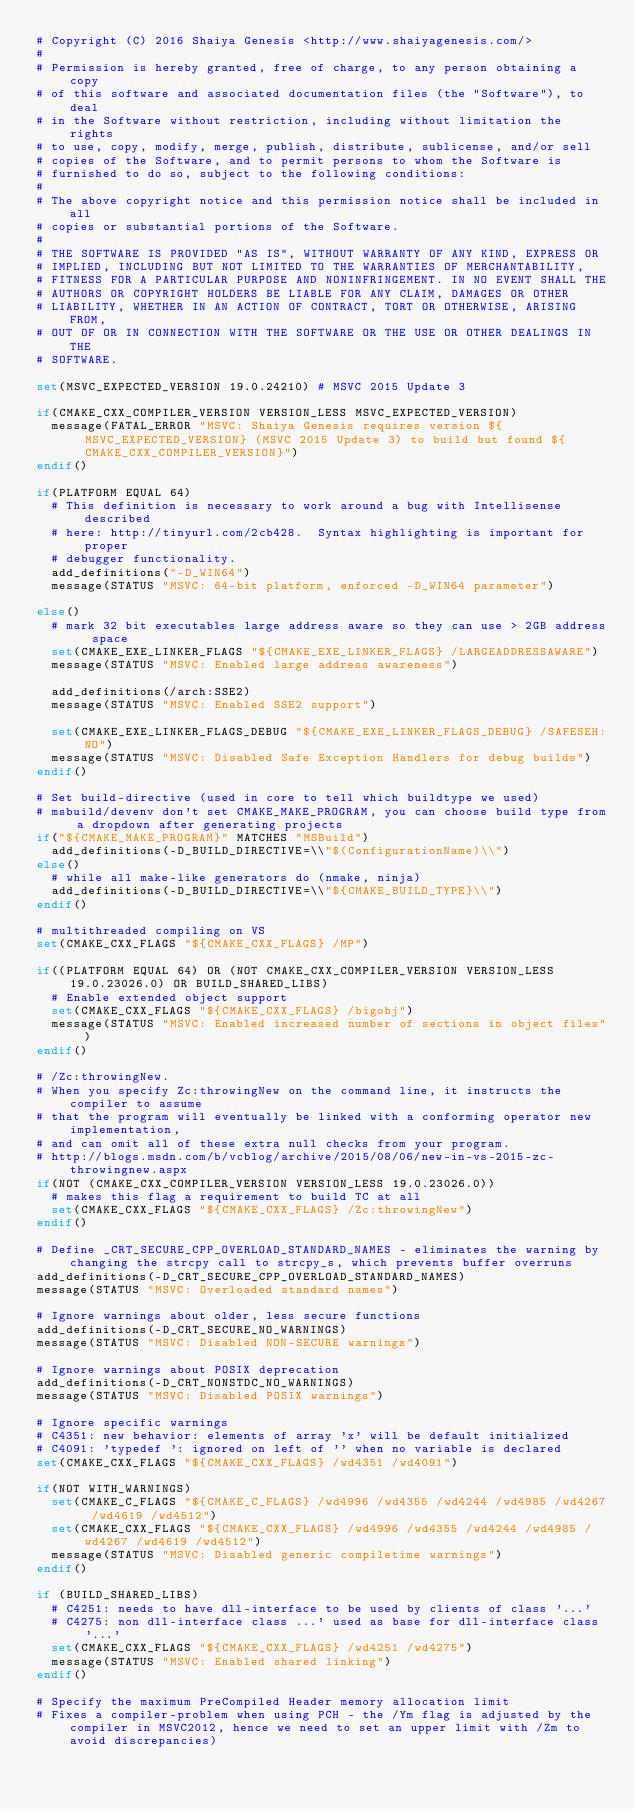<code> <loc_0><loc_0><loc_500><loc_500><_CMake_># Copyright (C) 2016 Shaiya Genesis <http://www.shaiyagenesis.com/>
#
# Permission is hereby granted, free of charge, to any person obtaining a copy
# of this software and associated documentation files (the "Software"), to deal
# in the Software without restriction, including without limitation the rights
# to use, copy, modify, merge, publish, distribute, sublicense, and/or sell
# copies of the Software, and to permit persons to whom the Software is
# furnished to do so, subject to the following conditions:
#
# The above copyright notice and this permission notice shall be included in all
# copies or substantial portions of the Software.
#
# THE SOFTWARE IS PROVIDED "AS IS", WITHOUT WARRANTY OF ANY KIND, EXPRESS OR
# IMPLIED, INCLUDING BUT NOT LIMITED TO THE WARRANTIES OF MERCHANTABILITY,
# FITNESS FOR A PARTICULAR PURPOSE AND NONINFRINGEMENT. IN NO EVENT SHALL THE
# AUTHORS OR COPYRIGHT HOLDERS BE LIABLE FOR ANY CLAIM, DAMAGES OR OTHER
# LIABILITY, WHETHER IN AN ACTION OF CONTRACT, TORT OR OTHERWISE, ARISING FROM,
# OUT OF OR IN CONNECTION WITH THE SOFTWARE OR THE USE OR OTHER DEALINGS IN THE
# SOFTWARE.

set(MSVC_EXPECTED_VERSION 19.0.24210) # MSVC 2015 Update 3

if(CMAKE_CXX_COMPILER_VERSION VERSION_LESS MSVC_EXPECTED_VERSION)
  message(FATAL_ERROR "MSVC: Shaiya Genesis requires version ${MSVC_EXPECTED_VERSION} (MSVC 2015 Update 3) to build but found ${CMAKE_CXX_COMPILER_VERSION}")
endif()

if(PLATFORM EQUAL 64)
  # This definition is necessary to work around a bug with Intellisense described
  # here: http://tinyurl.com/2cb428.  Syntax highlighting is important for proper
  # debugger functionality.
  add_definitions("-D_WIN64")
  message(STATUS "MSVC: 64-bit platform, enforced -D_WIN64 parameter")

else()
  # mark 32 bit executables large address aware so they can use > 2GB address space
  set(CMAKE_EXE_LINKER_FLAGS "${CMAKE_EXE_LINKER_FLAGS} /LARGEADDRESSAWARE")
  message(STATUS "MSVC: Enabled large address awareness")

  add_definitions(/arch:SSE2)
  message(STATUS "MSVC: Enabled SSE2 support")

  set(CMAKE_EXE_LINKER_FLAGS_DEBUG "${CMAKE_EXE_LINKER_FLAGS_DEBUG} /SAFESEH:NO")
  message(STATUS "MSVC: Disabled Safe Exception Handlers for debug builds")
endif()

# Set build-directive (used in core to tell which buildtype we used)
# msbuild/devenv don't set CMAKE_MAKE_PROGRAM, you can choose build type from a dropdown after generating projects
if("${CMAKE_MAKE_PROGRAM}" MATCHES "MSBuild")
  add_definitions(-D_BUILD_DIRECTIVE=\\"$(ConfigurationName)\\")
else()
  # while all make-like generators do (nmake, ninja)
  add_definitions(-D_BUILD_DIRECTIVE=\\"${CMAKE_BUILD_TYPE}\\")
endif()

# multithreaded compiling on VS
set(CMAKE_CXX_FLAGS "${CMAKE_CXX_FLAGS} /MP")

if((PLATFORM EQUAL 64) OR (NOT CMAKE_CXX_COMPILER_VERSION VERSION_LESS 19.0.23026.0) OR BUILD_SHARED_LIBS)
  # Enable extended object support
  set(CMAKE_CXX_FLAGS "${CMAKE_CXX_FLAGS} /bigobj")
  message(STATUS "MSVC: Enabled increased number of sections in object files")
endif()

# /Zc:throwingNew.
# When you specify Zc:throwingNew on the command line, it instructs the compiler to assume
# that the program will eventually be linked with a conforming operator new implementation,
# and can omit all of these extra null checks from your program.
# http://blogs.msdn.com/b/vcblog/archive/2015/08/06/new-in-vs-2015-zc-throwingnew.aspx
if(NOT (CMAKE_CXX_COMPILER_VERSION VERSION_LESS 19.0.23026.0))
  # makes this flag a requirement to build TC at all
  set(CMAKE_CXX_FLAGS "${CMAKE_CXX_FLAGS} /Zc:throwingNew")
endif()

# Define _CRT_SECURE_CPP_OVERLOAD_STANDARD_NAMES - eliminates the warning by changing the strcpy call to strcpy_s, which prevents buffer overruns
add_definitions(-D_CRT_SECURE_CPP_OVERLOAD_STANDARD_NAMES)
message(STATUS "MSVC: Overloaded standard names")

# Ignore warnings about older, less secure functions
add_definitions(-D_CRT_SECURE_NO_WARNINGS)
message(STATUS "MSVC: Disabled NON-SECURE warnings")

# Ignore warnings about POSIX deprecation
add_definitions(-D_CRT_NONSTDC_NO_WARNINGS)
message(STATUS "MSVC: Disabled POSIX warnings")

# Ignore specific warnings
# C4351: new behavior: elements of array 'x' will be default initialized
# C4091: 'typedef ': ignored on left of '' when no variable is declared
set(CMAKE_CXX_FLAGS "${CMAKE_CXX_FLAGS} /wd4351 /wd4091")

if(NOT WITH_WARNINGS)
  set(CMAKE_C_FLAGS "${CMAKE_C_FLAGS} /wd4996 /wd4355 /wd4244 /wd4985 /wd4267 /wd4619 /wd4512")
  set(CMAKE_CXX_FLAGS "${CMAKE_CXX_FLAGS} /wd4996 /wd4355 /wd4244 /wd4985 /wd4267 /wd4619 /wd4512")
  message(STATUS "MSVC: Disabled generic compiletime warnings")
endif()

if (BUILD_SHARED_LIBS)
  # C4251: needs to have dll-interface to be used by clients of class '...'
  # C4275: non dll-interface class ...' used as base for dll-interface class '...'
  set(CMAKE_CXX_FLAGS "${CMAKE_CXX_FLAGS} /wd4251 /wd4275")
  message(STATUS "MSVC: Enabled shared linking")
endif()

# Specify the maximum PreCompiled Header memory allocation limit
# Fixes a compiler-problem when using PCH - the /Ym flag is adjusted by the compiler in MSVC2012, hence we need to set an upper limit with /Zm to avoid discrepancies)</code> 